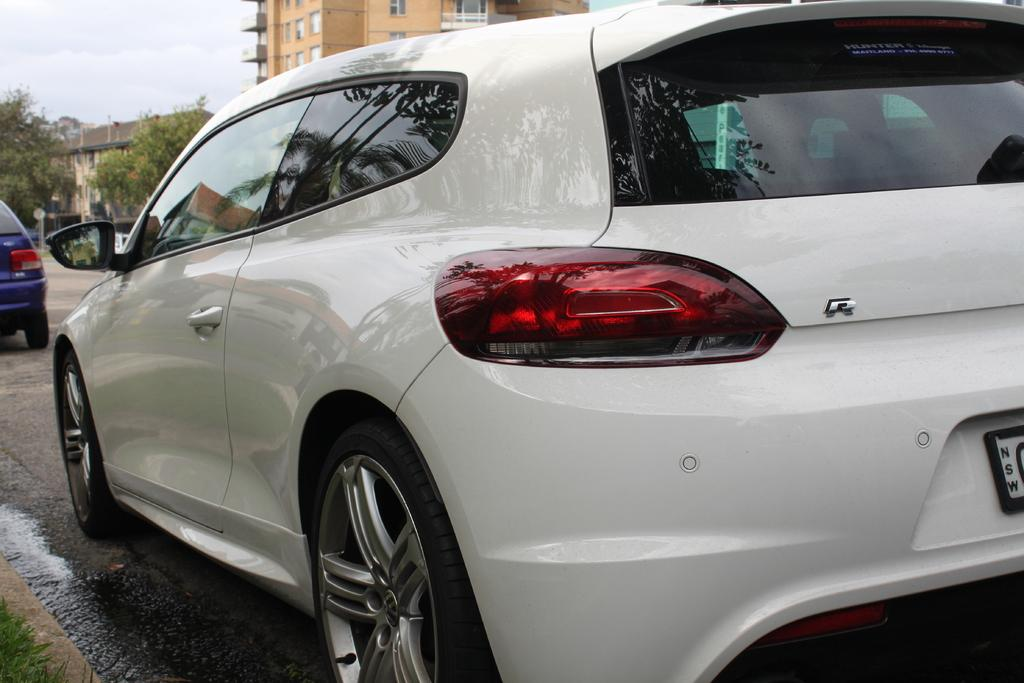What types of objects are present in the image? There are vehicles, poles, and buildings in the image. What can be seen on the ground in the image? The ground is visible in the image, and there is grass on the bottom left of the image. What other natural elements are present in the image? There are trees in the image. What is visible in the background of the image? The sky is visible in the image. Can you tell me who is winning the chess game in the image? There is no chess game present in the image. What type of haircut does the person on the swing have in the image? There is no person on a swing present in the image. 